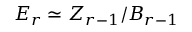Convert formula to latex. <formula><loc_0><loc_0><loc_500><loc_500>E _ { r } \simeq Z _ { r - 1 } / B _ { r - 1 }</formula> 